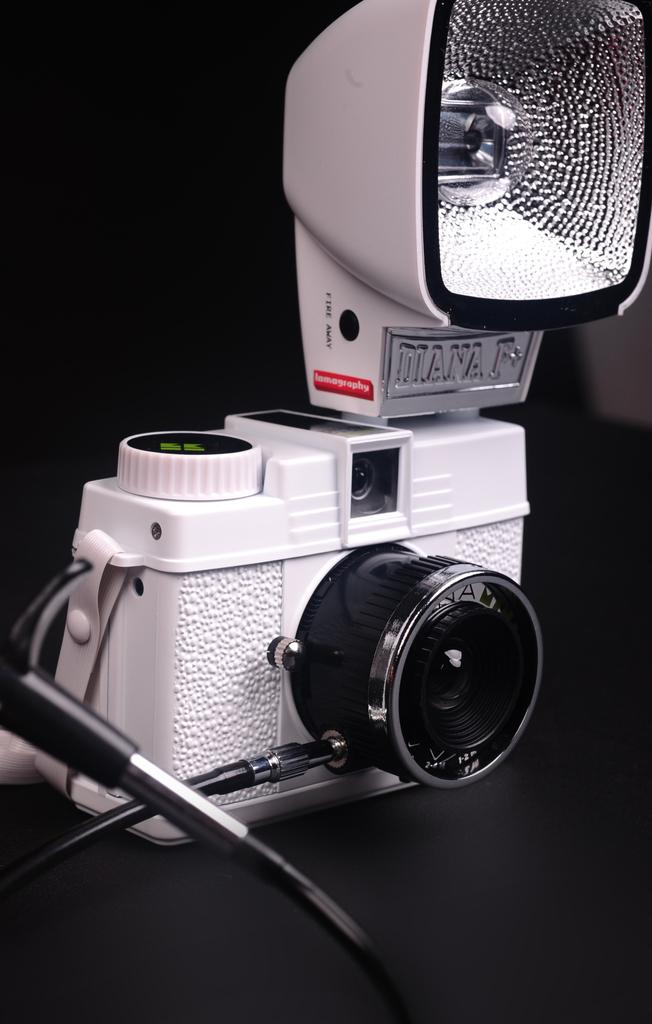What is the main object in the image? There is a camera in the image. What can be observed about the lighting in the image? The background of the image is dark. What is the belief of the grandmother about the plane in the image? There is no grandmother or plane present in the image, so it is not possible to answer that question. 